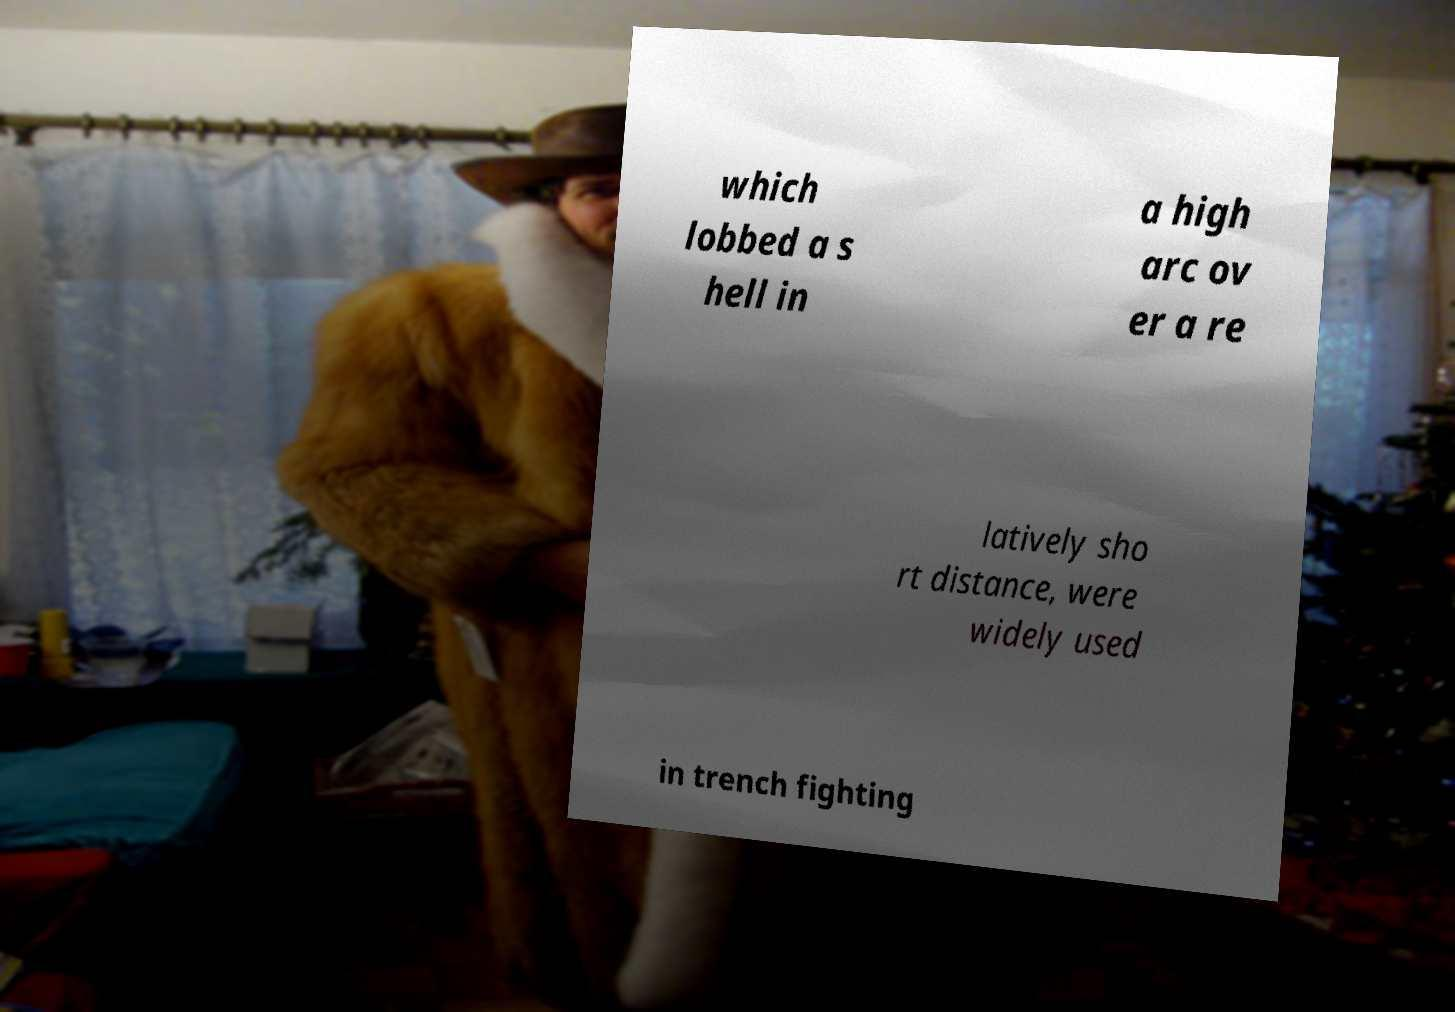Can you accurately transcribe the text from the provided image for me? which lobbed a s hell in a high arc ov er a re latively sho rt distance, were widely used in trench fighting 